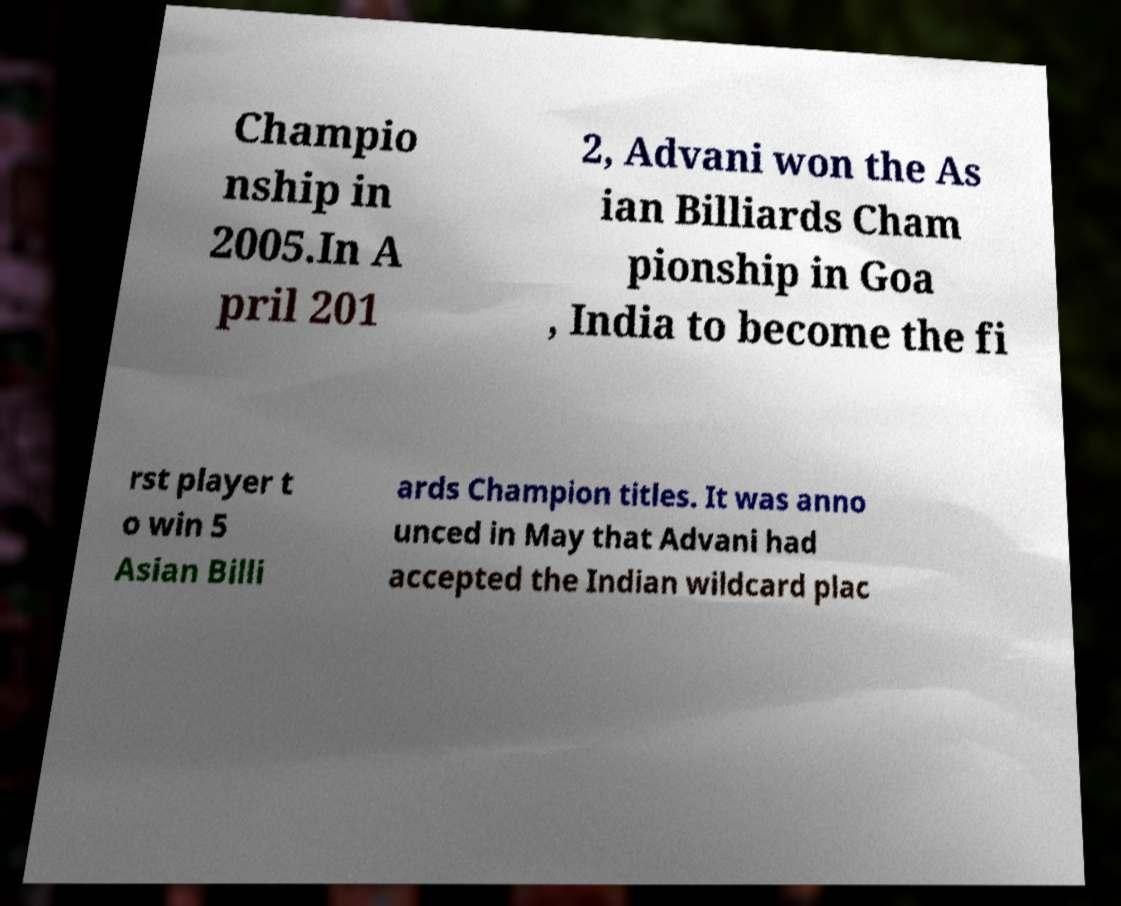I need the written content from this picture converted into text. Can you do that? Champio nship in 2005.In A pril 201 2, Advani won the As ian Billiards Cham pionship in Goa , India to become the fi rst player t o win 5 Asian Billi ards Champion titles. It was anno unced in May that Advani had accepted the Indian wildcard plac 